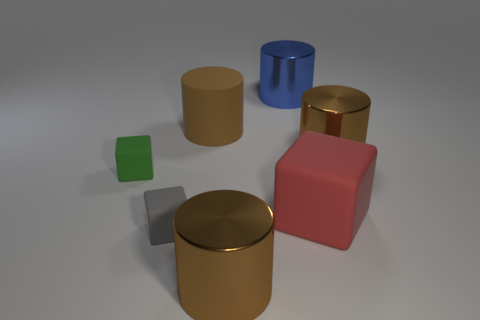Subtract all purple blocks. How many brown cylinders are left? 3 Add 2 blue metal balls. How many objects exist? 9 Subtract all cubes. How many objects are left? 4 Subtract 0 purple cubes. How many objects are left? 7 Subtract all large brown metallic cylinders. Subtract all small gray matte things. How many objects are left? 4 Add 3 brown things. How many brown things are left? 6 Add 3 small cubes. How many small cubes exist? 5 